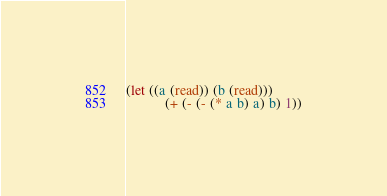Convert code to text. <code><loc_0><loc_0><loc_500><loc_500><_Lisp_>(let ((a (read)) (b (read)))
	       (+ (- (- (* a b) a) b) 1))</code> 